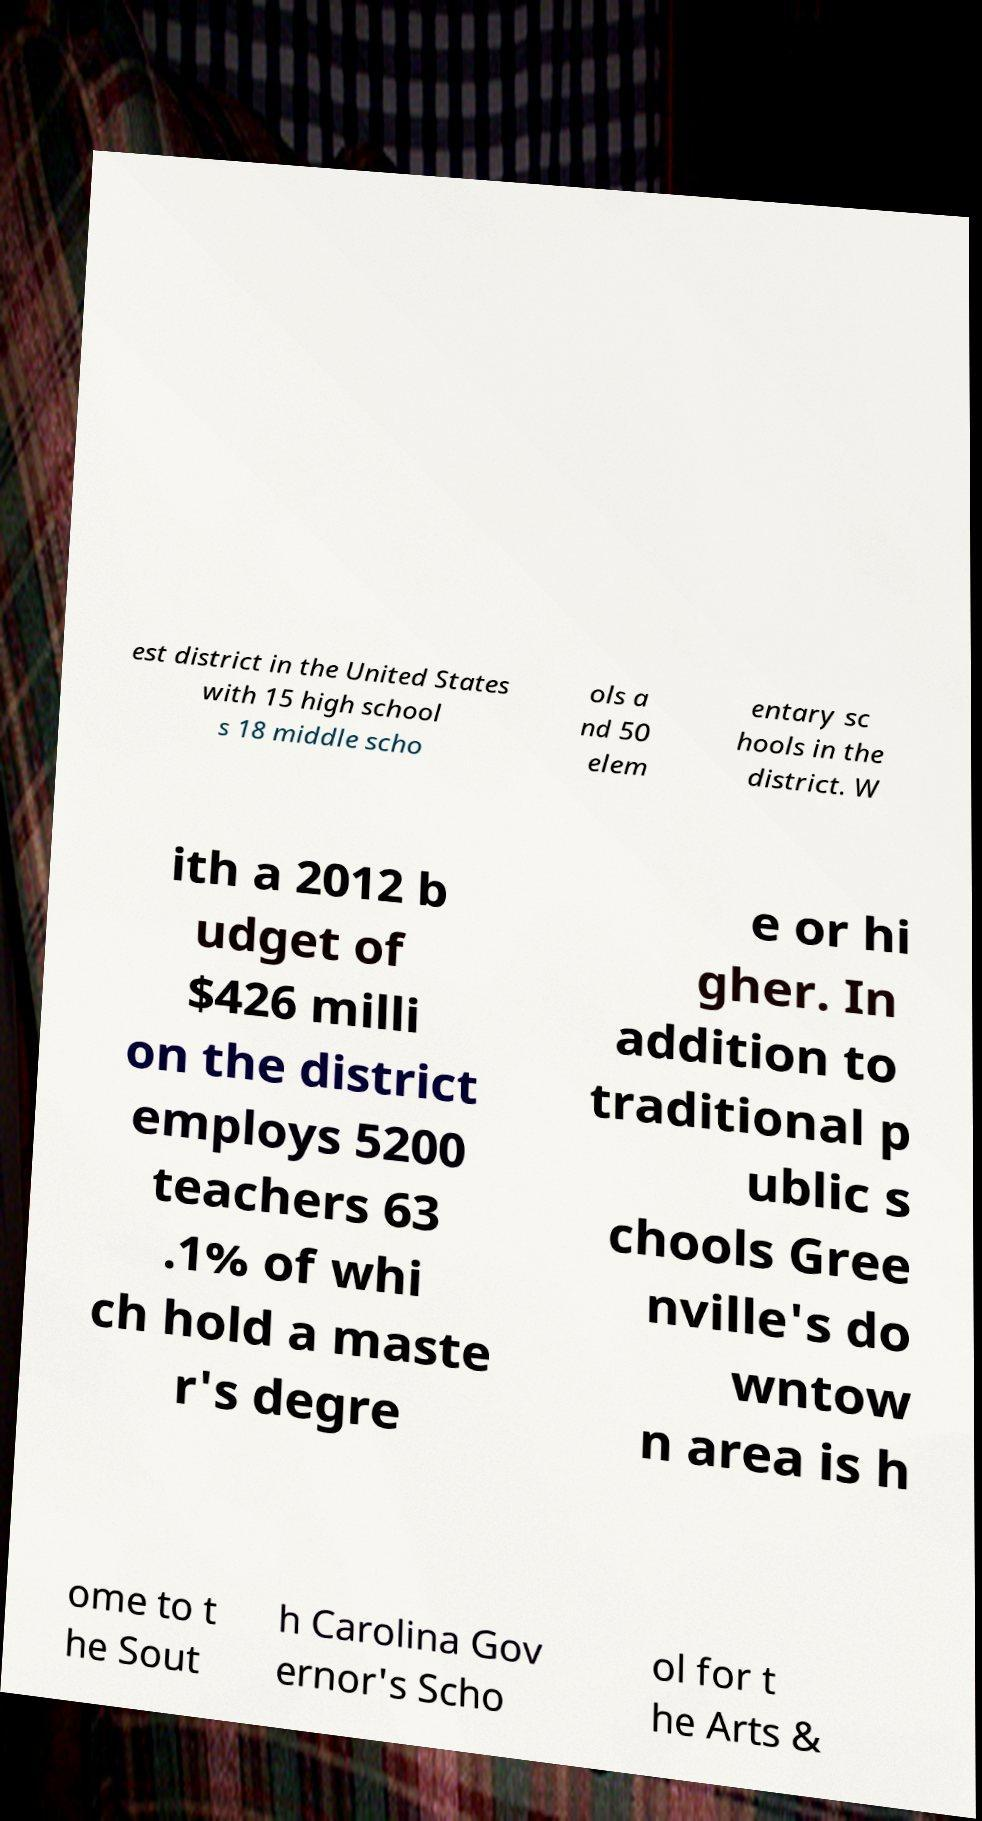Could you extract and type out the text from this image? est district in the United States with 15 high school s 18 middle scho ols a nd 50 elem entary sc hools in the district. W ith a 2012 b udget of $426 milli on the district employs 5200 teachers 63 .1% of whi ch hold a maste r's degre e or hi gher. In addition to traditional p ublic s chools Gree nville's do wntow n area is h ome to t he Sout h Carolina Gov ernor's Scho ol for t he Arts & 